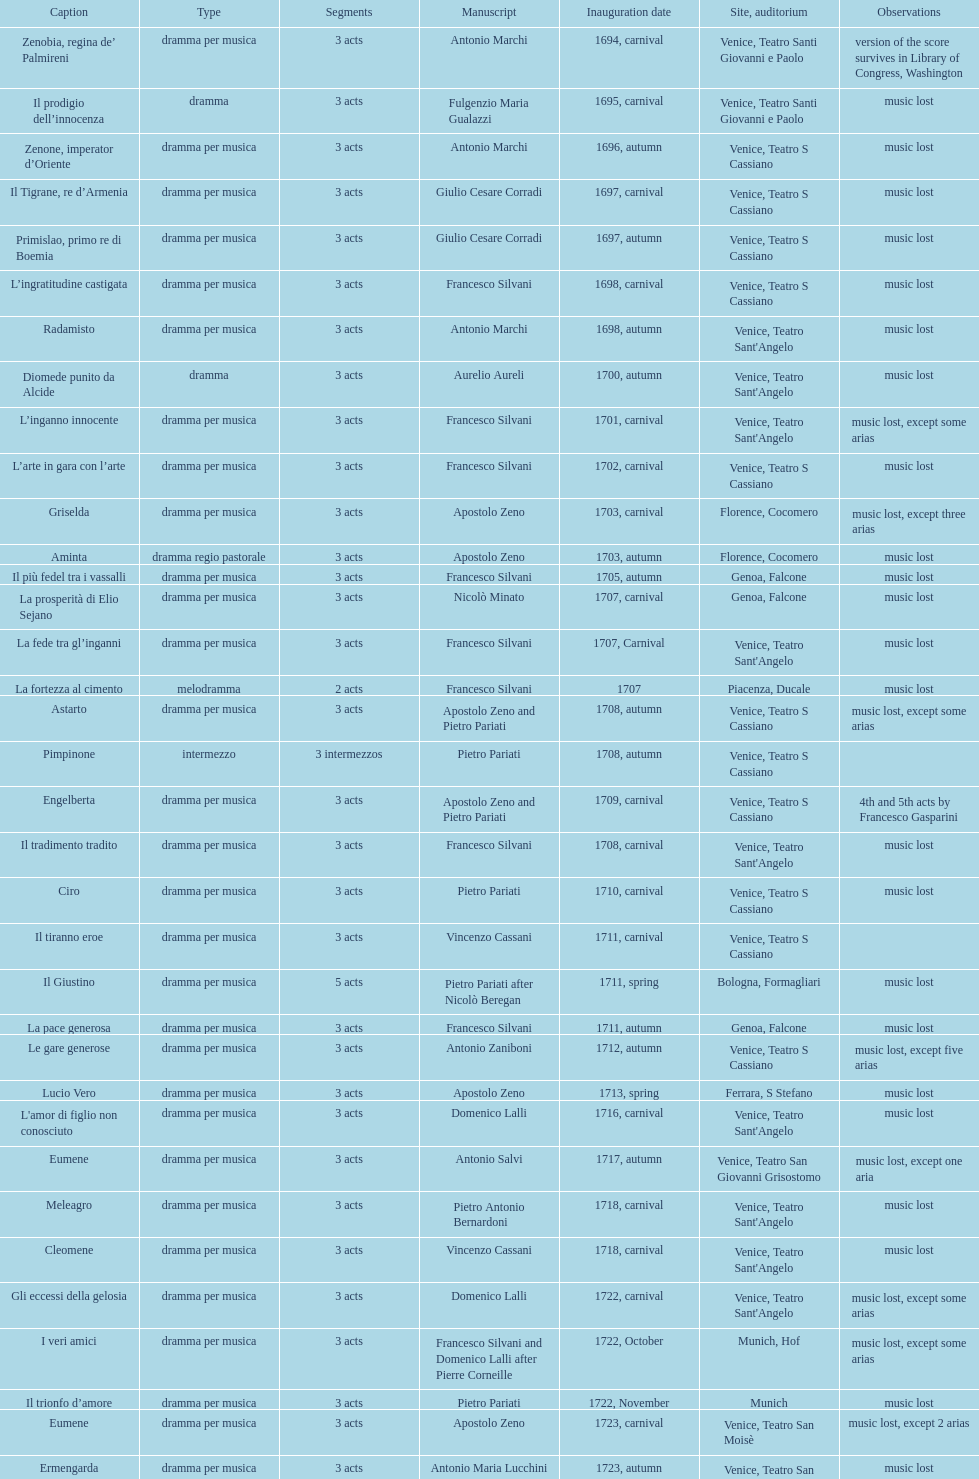What is next after ardelinda? Candalide. 